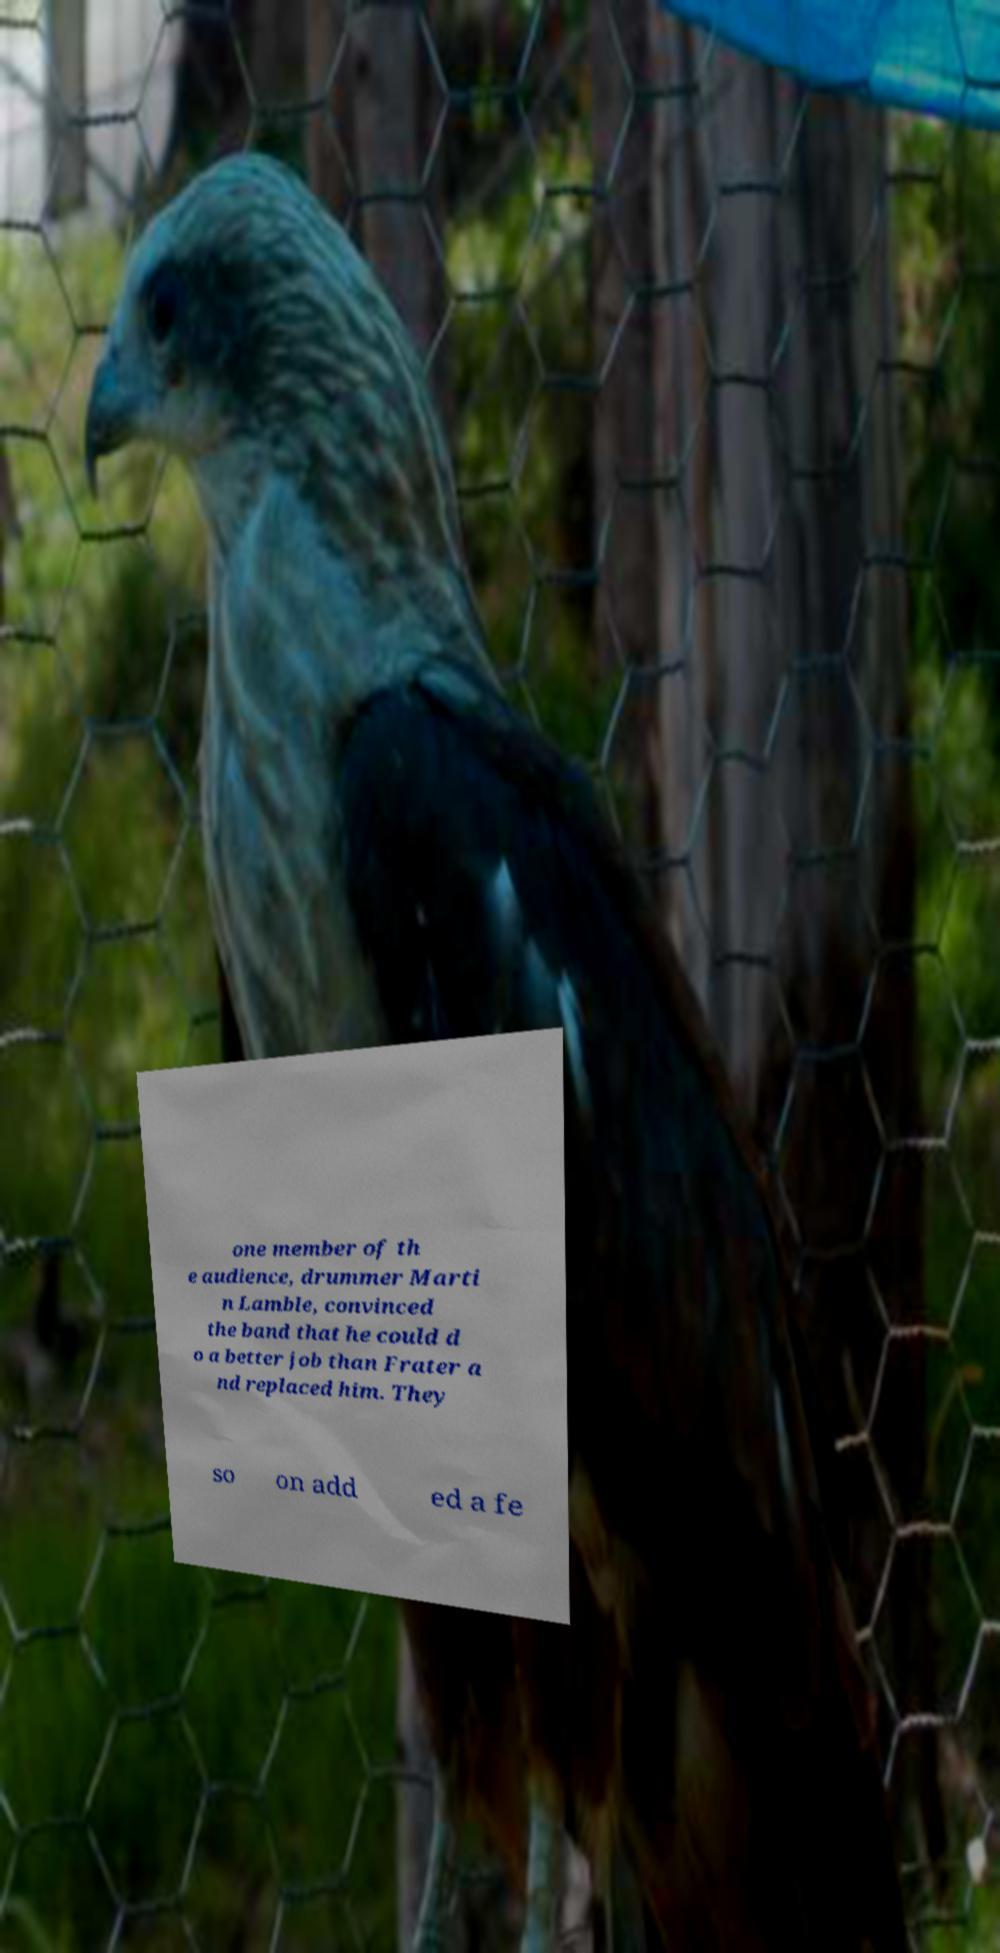Could you extract and type out the text from this image? one member of th e audience, drummer Marti n Lamble, convinced the band that he could d o a better job than Frater a nd replaced him. They so on add ed a fe 